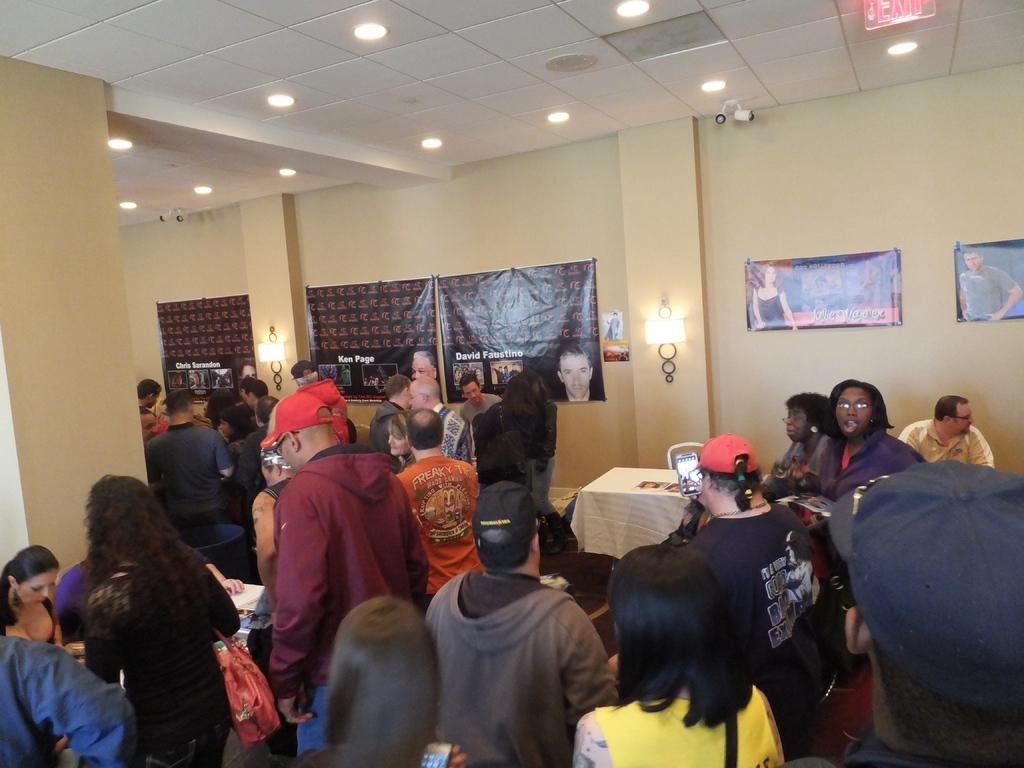How many people are in the room? There are people in the room, but the exact number is not specified in the facts. What is one piece of furniture in the room? There is a table in the room. What type of lighting is present in the room? There are lamps and lights in the room. What decorations are on the walls? There are posters on the walls. Is there any security equipment in the room? Yes, there is a CCTV camera at the top of the room. What type of hat is the pet wearing in the room? There is no pet or hat present in the room; the facts only mention people, a table, lamps, lights, posters, and a CCTV camera. 